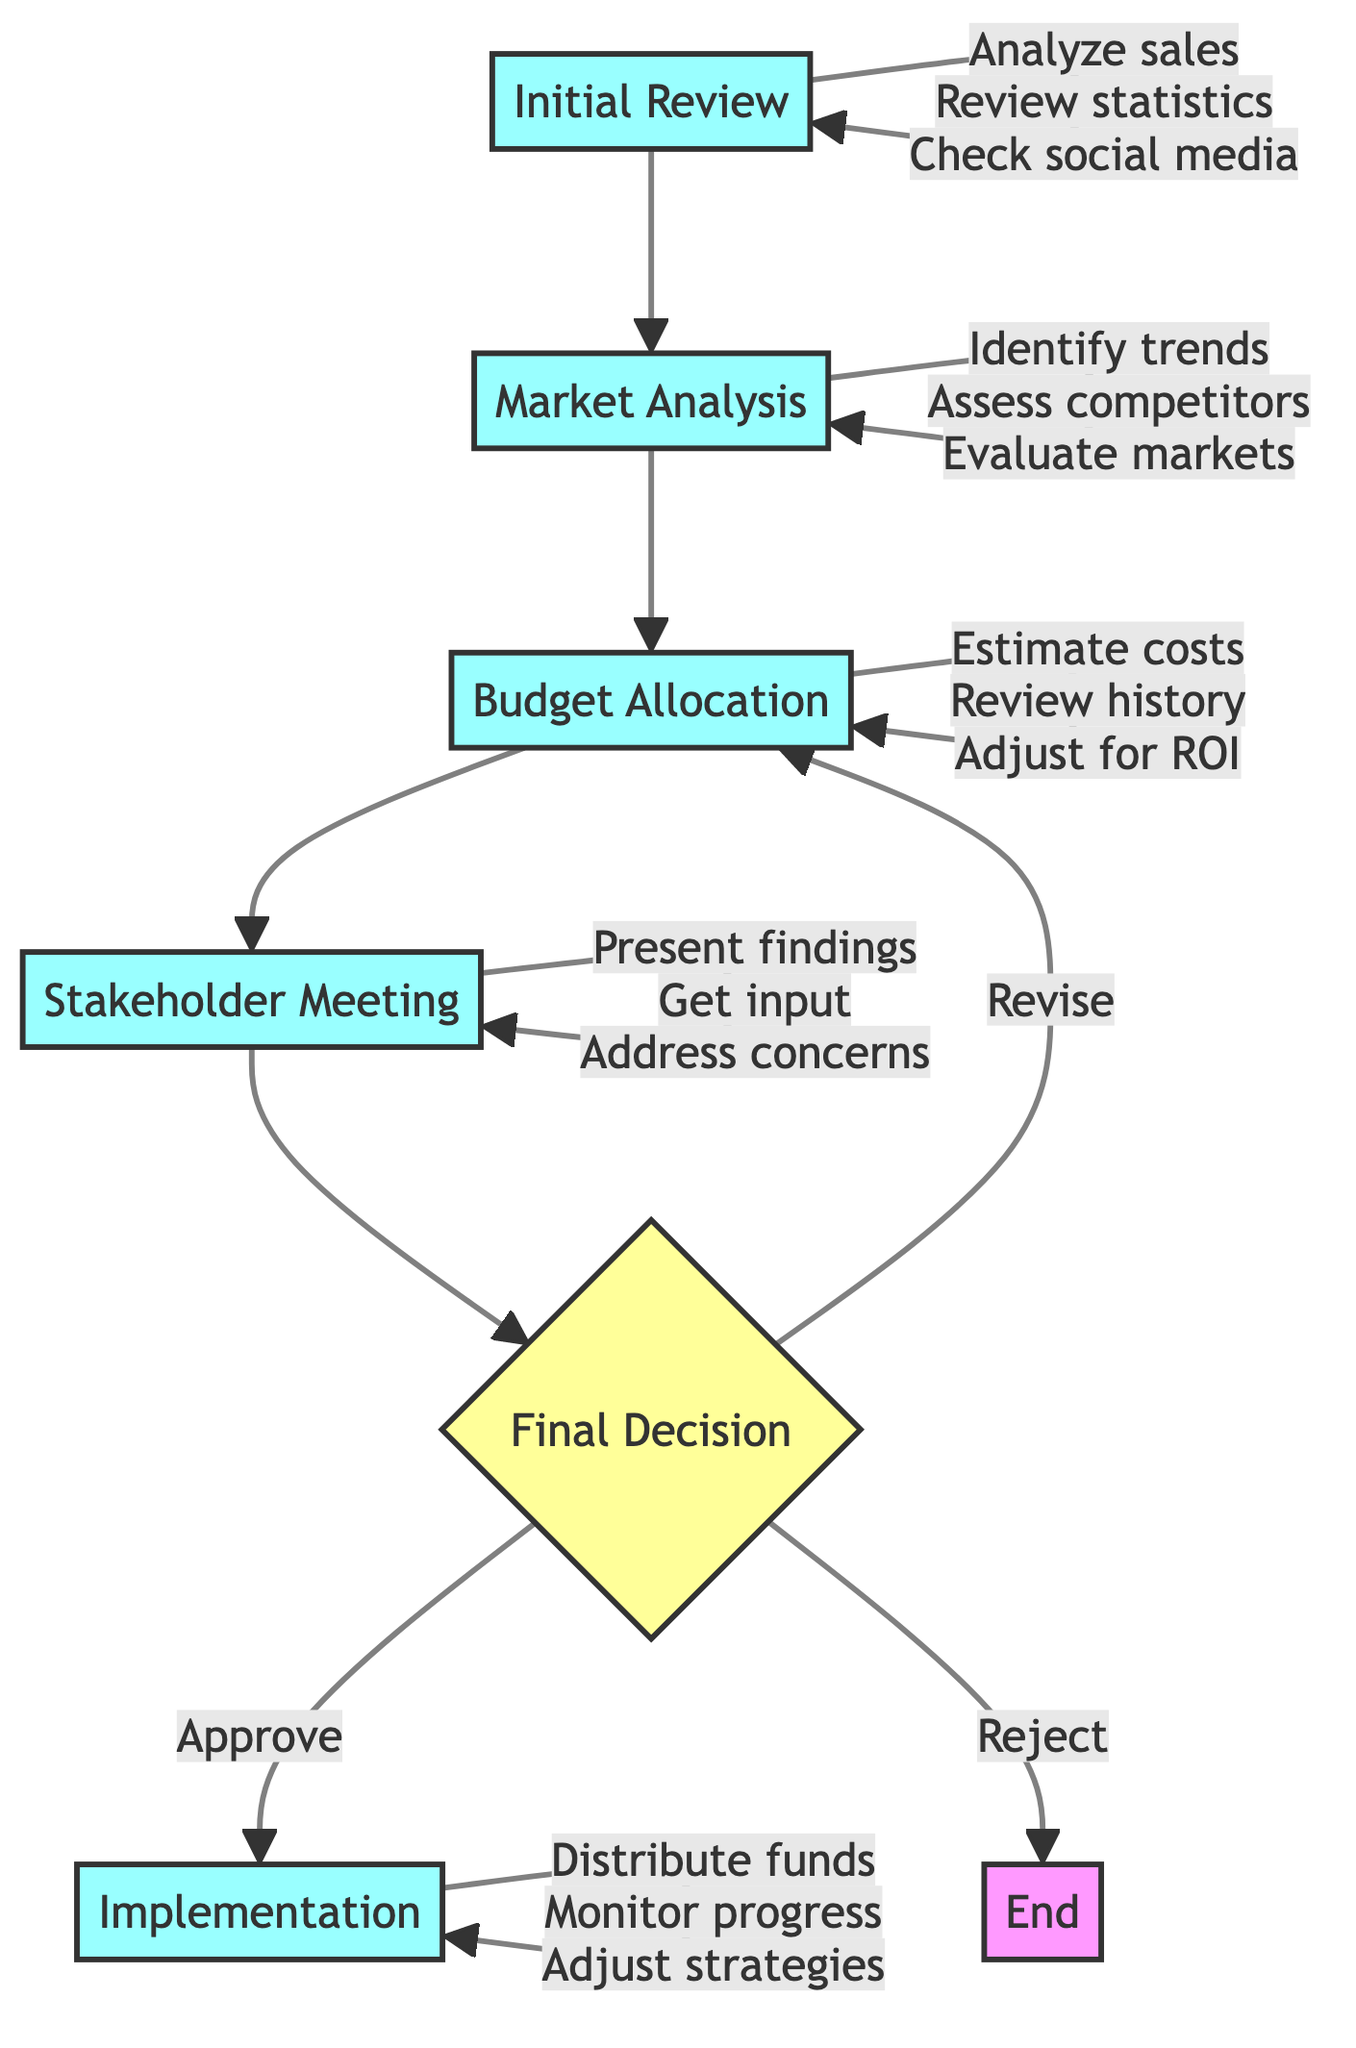What is the first step in the decision-making process? The first step in the diagram is "Initial Review," which is clearly indicated as the starting point of the flowchart.
Answer: Initial Review How many main steps are there in the process? The main steps include Initial Review, Market Analysis, Budget Allocation, Stakeholder Meeting, Final Decision, and Implementation, totaling six steps.
Answer: Six What is the outcome if the final decision is to reject the proposal? According to the flowchart, if the final decision is to reject, the process ends without moving to implementation, indicating no funding allocated.
Answer: End Which step involves presenting findings to the board? The "Stakeholder Meeting" is the specific step where findings are presented to the board of directors for discussion and input.
Answer: Stakeholder Meeting What action is taken in the Implementation step? In the Implementation step, one of the actions listed is to distribute funds across production stages, which is essential for executing the project.
Answer: Distribute funds If market analysis is negative, which step should be revisited? If the market analysis is less favorable, the flowchart indicates returning to the "Budget Allocation" step for adjustments based on the information collected.
Answer: Budget Allocation How does the process move from "Final Decision" to "Implementation"? The transition occurs if the decision is to approve the budget, allowing the process to proceed directly to Implementation for execution.
Answer: Approve What does the budget allocation step focus on primarily? The budget allocation step primarily focuses on estimating costs for production, marketing, and distribution, crucial for determining the project budget.
Answer: Estimate costs What component does the final decision step require approval from? The final decision involves approval from the board of directors, as indicated by the arrows leading to potential outcomes like approval or revision.
Answer: Board of directors 